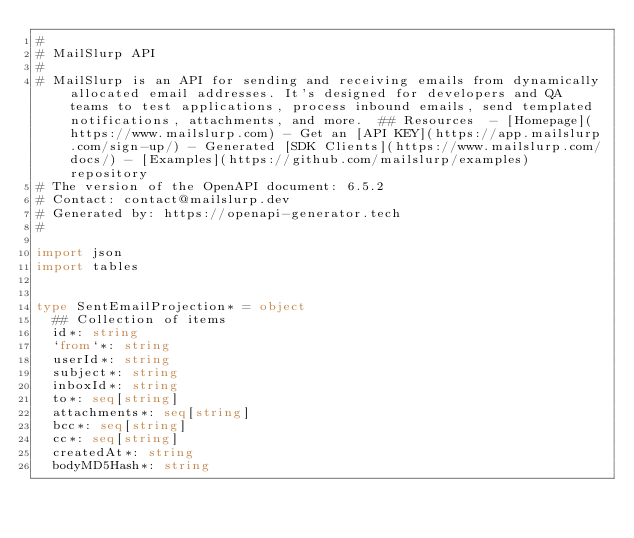<code> <loc_0><loc_0><loc_500><loc_500><_Nim_>#
# MailSlurp API
# 
# MailSlurp is an API for sending and receiving emails from dynamically allocated email addresses. It's designed for developers and QA teams to test applications, process inbound emails, send templated notifications, attachments, and more.  ## Resources  - [Homepage](https://www.mailslurp.com) - Get an [API KEY](https://app.mailslurp.com/sign-up/) - Generated [SDK Clients](https://www.mailslurp.com/docs/) - [Examples](https://github.com/mailslurp/examples) repository
# The version of the OpenAPI document: 6.5.2
# Contact: contact@mailslurp.dev
# Generated by: https://openapi-generator.tech
#

import json
import tables


type SentEmailProjection* = object
  ## Collection of items
  id*: string
  `from`*: string
  userId*: string
  subject*: string
  inboxId*: string
  to*: seq[string]
  attachments*: seq[string]
  bcc*: seq[string]
  cc*: seq[string]
  createdAt*: string
  bodyMD5Hash*: string
</code> 